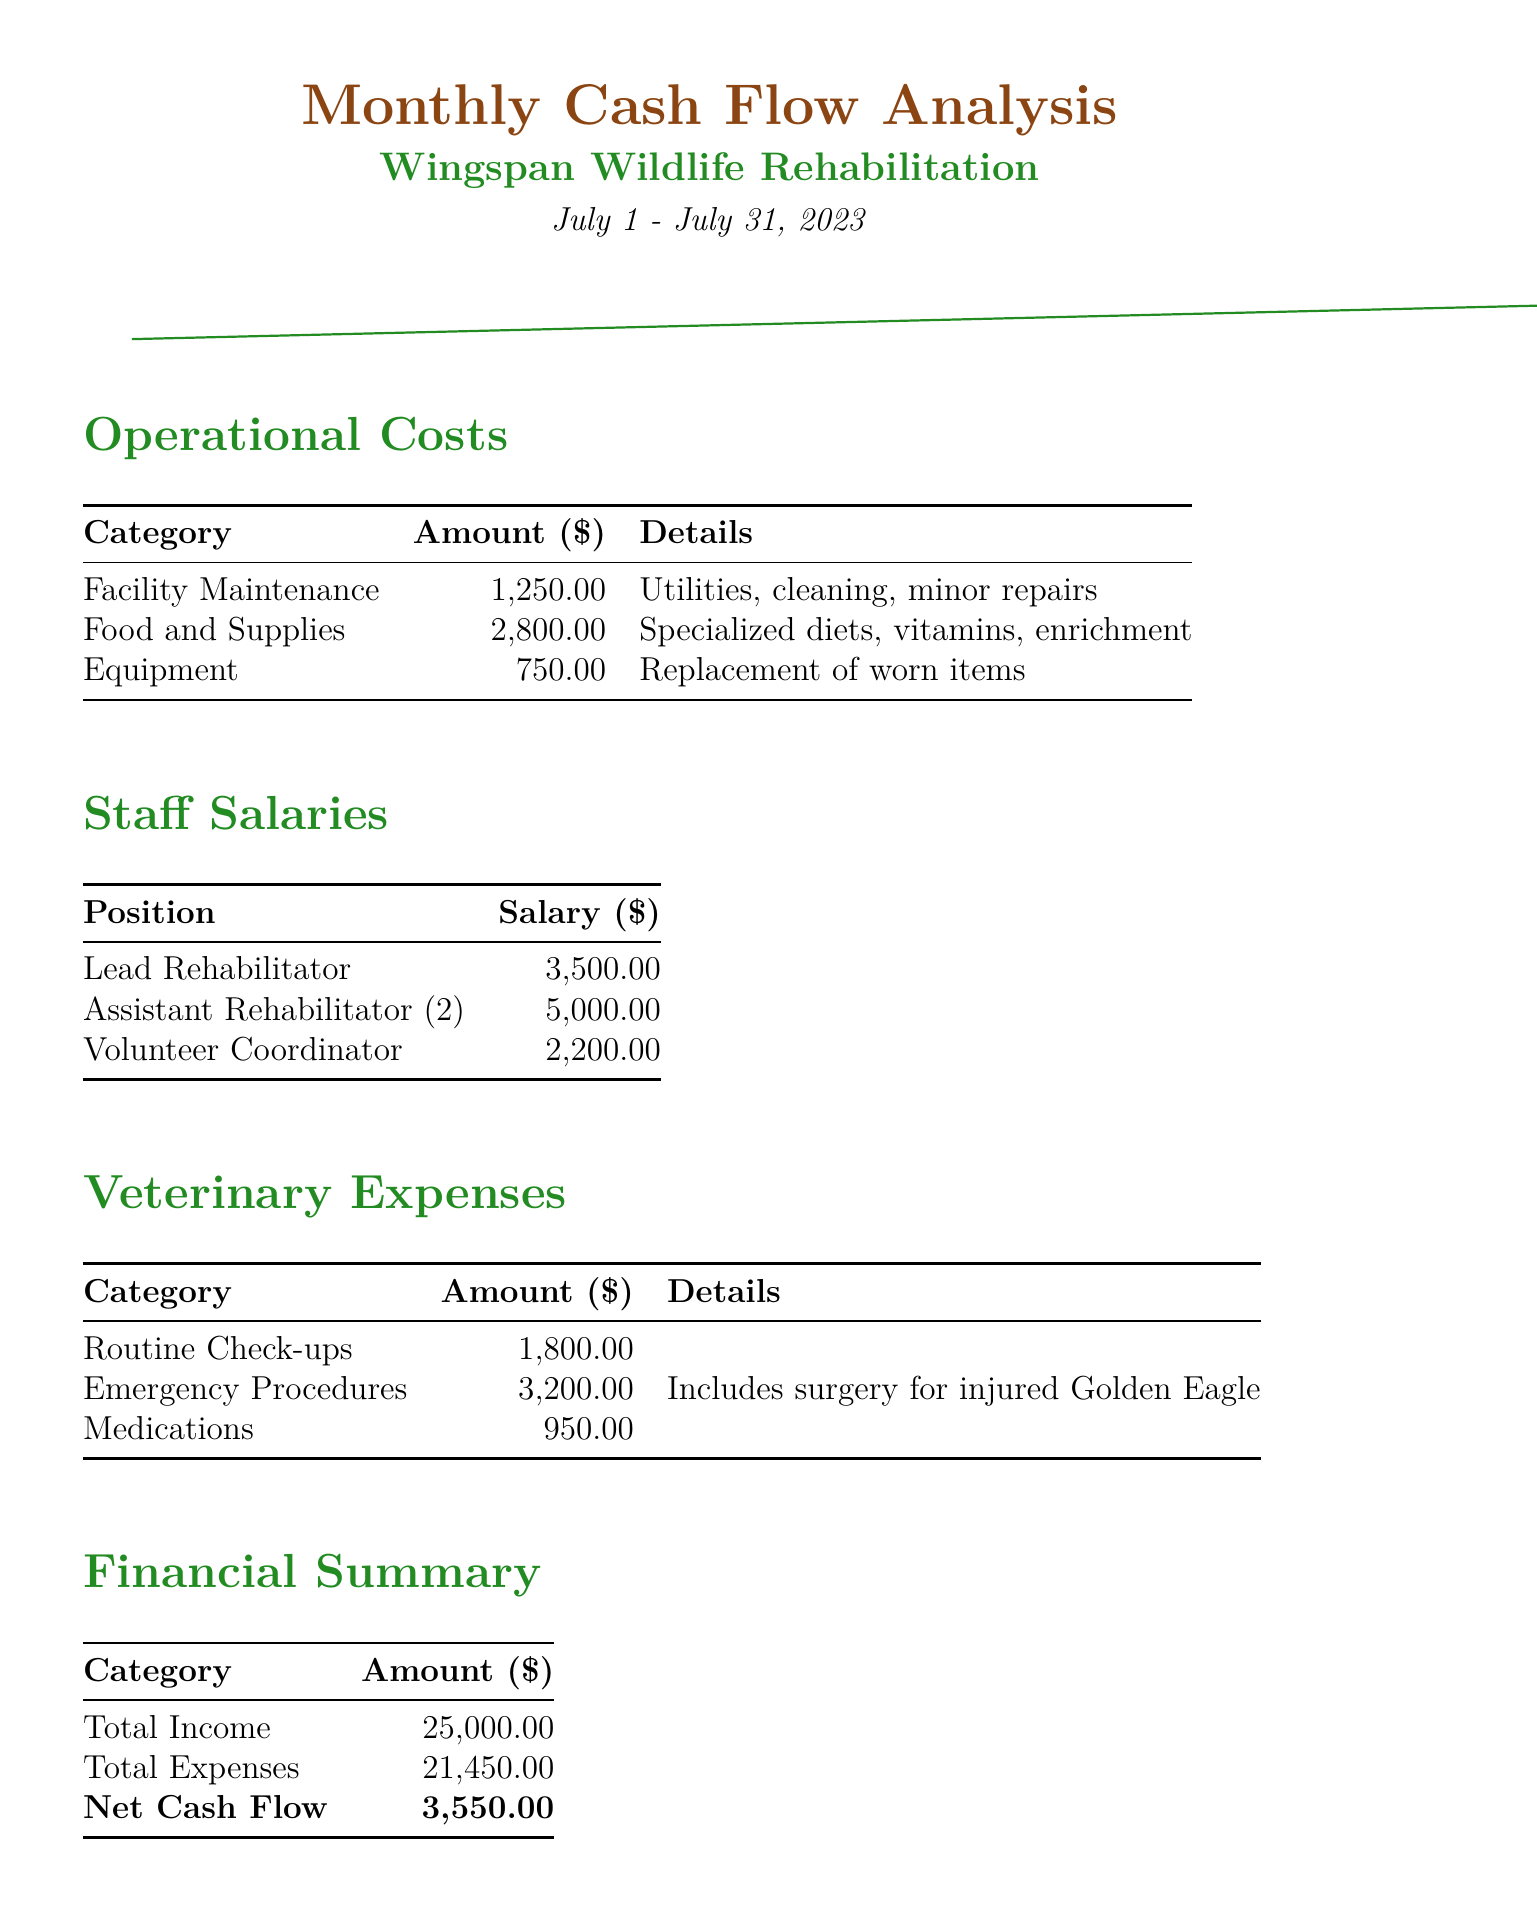What is the total income? The total income is explicitly stated in the financial summary section of the document.
Answer: $25000.00 What are the operational costs for Food and Supplies? The amount allocated to Food and Supplies is detailed in the operational costs table.
Answer: $2800.00 How much did veterinary expenses for Emergency Procedures amount to? The amount for Emergency Procedures is specified in the veterinary expenses section of the document.
Answer: $3200.00 What is the net cash flow for the month? The net cash flow is provided in the financial summary as the difference between total income and total expenses.
Answer: $3550.00 How many staff positions are listed in the staff salaries section? The staff salaries section lists the positions, where each distinct role counts towards the total.
Answer: 3 What notable event involved released raptors? The notable events list specifically mentions the successful rehabilitation and release of certain birds.
Answer: 5 Red-tailed Hawks What was the total amount spent on facility maintenance? The facility maintenance cost is found within the operational costs section of the document.
Answer: $1250.00 How much is the salary of the Lead Rehabilitator? The salary for the Lead Rehabilitator is detailed in the staff salaries table.
Answer: $3500.00 What percentage increase in volunteers was achieved? This detail is mentioned within the notable events, indicating the effect of social media outreach.
Answer: 20 percent 